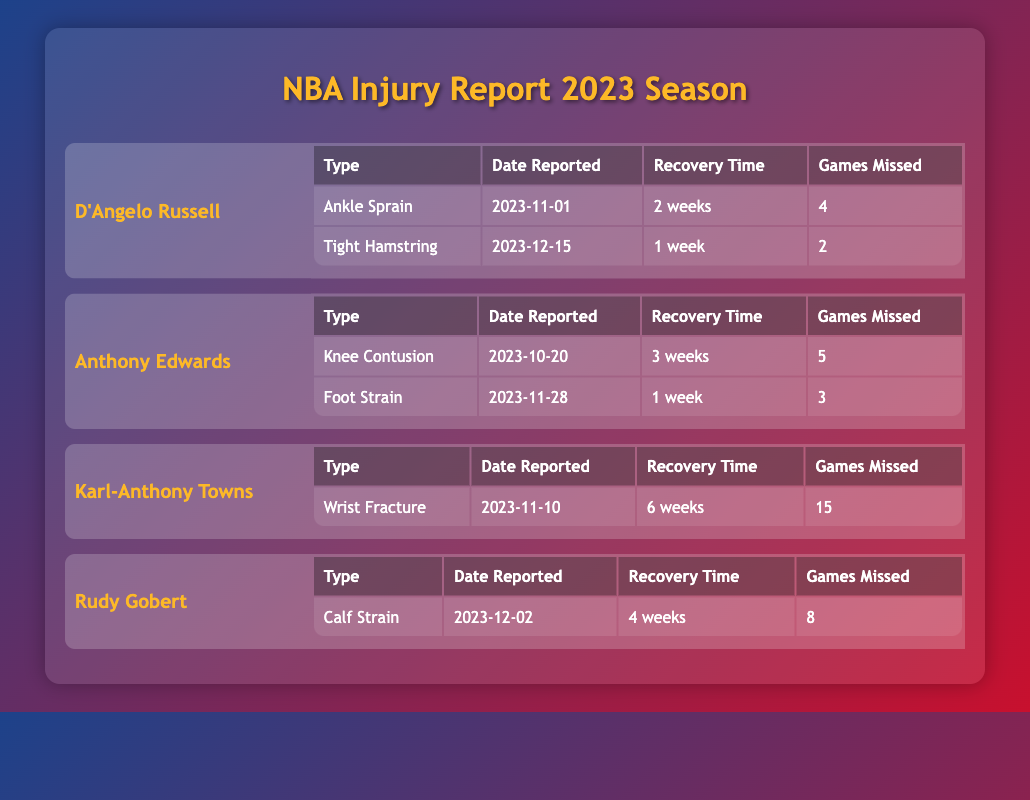What injuries did D'Angelo Russell sustain during the 2023 season? According to the table, D'Angelo Russell suffered an Ankle Sprain and a Tight Hamstring during the 2023 season.
Answer: Ankle Sprain and Tight Hamstring How many games did Anthony Edwards miss due to his injuries? From the table, Anthony Edwards missed a total of 5 games for his Knee Contusion and 3 games for his Foot Strain. Summing these gives 5 + 3 = 8 games missed.
Answer: 8 games Which player had the longest recovery time, and what was the injury? The table states that Karl-Anthony Towns had a Wrist Fracture with the longest recovery time of 6 weeks.
Answer: Karl-Anthony Towns, Wrist Fracture Did Rudy Gobert suffer an injury that required less than a month of recovery? The table indicates that Rudy Gobert's Calf Strain required 4 weeks of recovery, which is less than a month.
Answer: Yes What is the average recovery time for injuries listed for D'Angelo Russell? D'Angelo Russell's injuries had recovery times of 2 weeks and 1 week. To find the average, convert them to days (14 and 7), sum them (14 + 7 = 21), and then divide by the number of injuries (2): 21 / 2 = 10.5 days, which is approximately 1.5 weeks.
Answer: 1.5 weeks How many total games were missed by all players due to their injuries? The table lists the total games missed by each player: D'Angelo Russell missed 6, Anthony Edwards missed 8, Karl-Anthony Towns missed 15, and Rudy Gobert missed 8. Adding these together gives: 6 + 8 + 15 + 8 = 37 games missed overall.
Answer: 37 games Was D'Angelo Russell's injury report more than two injuries in total? The table shows that D'Angelo Russell had two injuries reported during the season, which is not more than two.
Answer: No Which player reported an injury most recently and what was the injury? According to the table, D'Angelo Russell reported his Tight Hamstring injury on December 15, 2023, which is the most recent injury report listed.
Answer: D'Angelo Russell, Tight Hamstring 